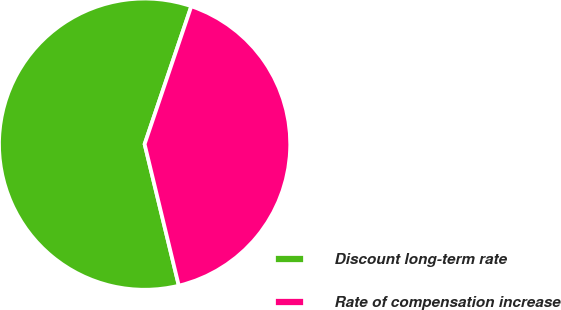<chart> <loc_0><loc_0><loc_500><loc_500><pie_chart><fcel>Discount long-term rate<fcel>Rate of compensation increase<nl><fcel>58.97%<fcel>41.03%<nl></chart> 